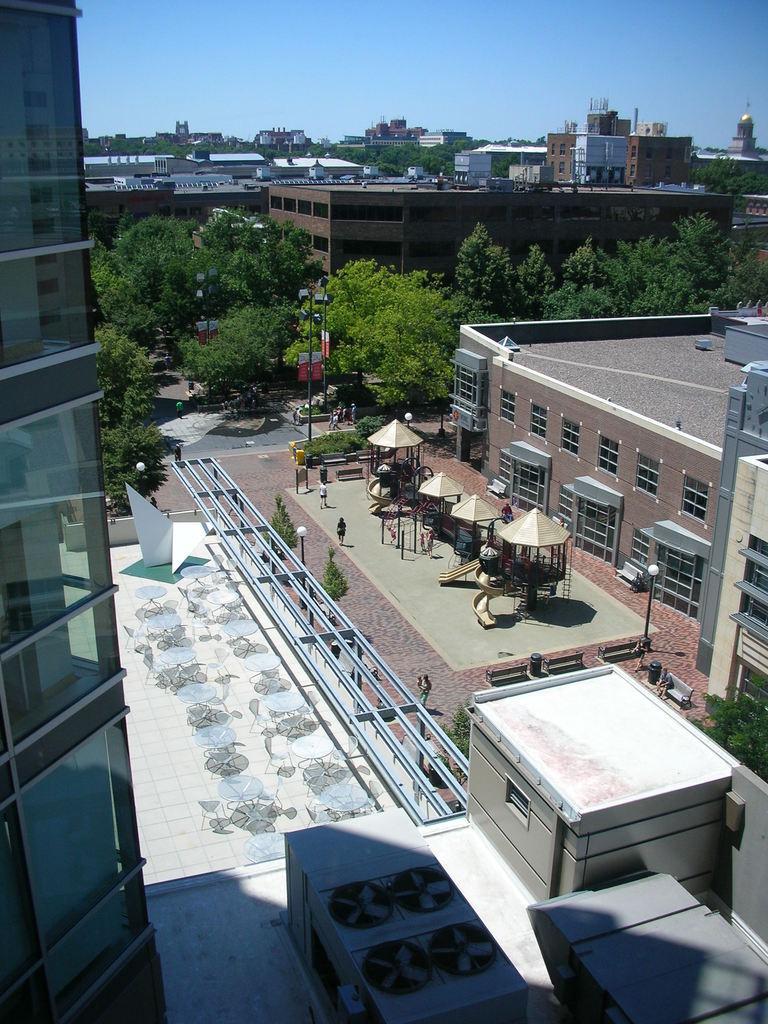Can you describe this image briefly? This is a picture of the city, where there are buildings, lights, poles, boards, trees, road, outdoor playground , group of people standing, and in the background there is sky. 